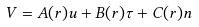Convert formula to latex. <formula><loc_0><loc_0><loc_500><loc_500>V = A ( r ) u + B ( r ) \tau + C ( r ) n</formula> 